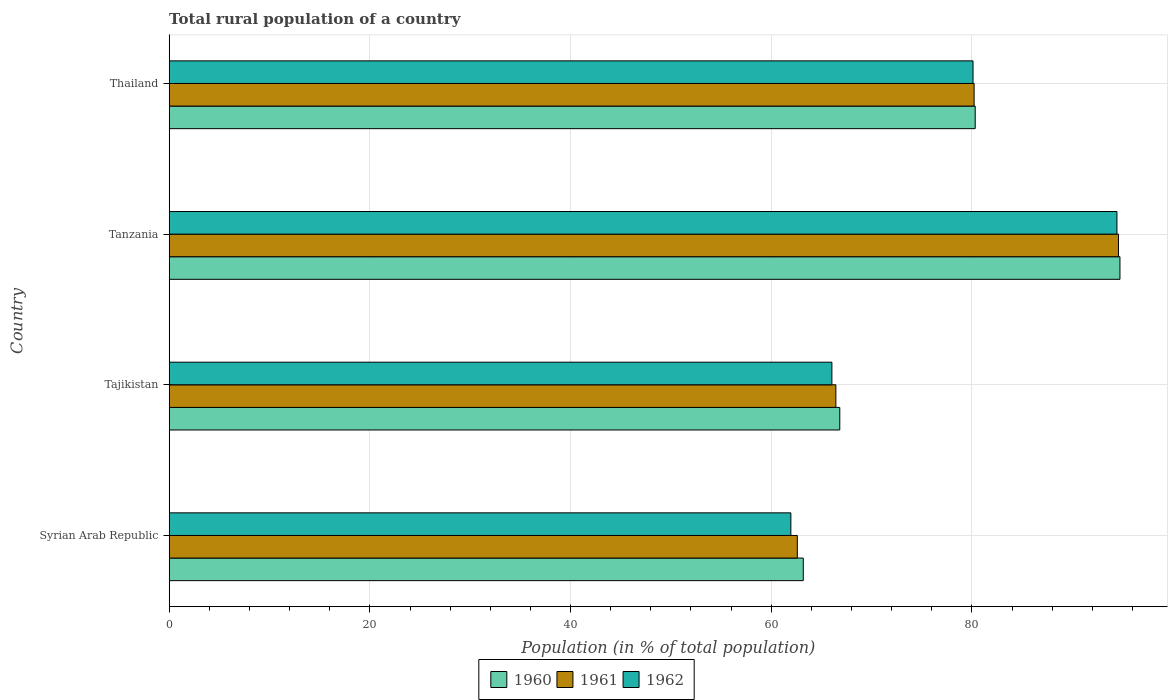How many different coloured bars are there?
Give a very brief answer. 3. How many groups of bars are there?
Keep it short and to the point. 4. Are the number of bars per tick equal to the number of legend labels?
Offer a very short reply. Yes. How many bars are there on the 3rd tick from the top?
Your answer should be compact. 3. What is the label of the 4th group of bars from the top?
Give a very brief answer. Syrian Arab Republic. What is the rural population in 1960 in Syrian Arab Republic?
Make the answer very short. 63.19. Across all countries, what is the maximum rural population in 1960?
Your answer should be very brief. 94.75. Across all countries, what is the minimum rural population in 1962?
Your response must be concise. 61.96. In which country was the rural population in 1962 maximum?
Ensure brevity in your answer.  Tanzania. In which country was the rural population in 1960 minimum?
Your response must be concise. Syrian Arab Republic. What is the total rural population in 1960 in the graph?
Offer a very short reply. 305.11. What is the difference between the rural population in 1961 in Syrian Arab Republic and that in Tanzania?
Your answer should be compact. -32. What is the difference between the rural population in 1960 in Syrian Arab Republic and the rural population in 1962 in Tanzania?
Make the answer very short. -31.26. What is the average rural population in 1961 per country?
Keep it short and to the point. 75.97. What is the difference between the rural population in 1960 and rural population in 1962 in Syrian Arab Republic?
Provide a short and direct response. 1.24. What is the ratio of the rural population in 1960 in Syrian Arab Republic to that in Thailand?
Your response must be concise. 0.79. What is the difference between the highest and the second highest rural population in 1961?
Ensure brevity in your answer.  14.39. What is the difference between the highest and the lowest rural population in 1961?
Provide a short and direct response. 32. What does the 3rd bar from the bottom in Tajikistan represents?
Offer a very short reply. 1962. Are the values on the major ticks of X-axis written in scientific E-notation?
Make the answer very short. No. Does the graph contain grids?
Your response must be concise. Yes. Where does the legend appear in the graph?
Offer a terse response. Bottom center. How many legend labels are there?
Make the answer very short. 3. How are the legend labels stacked?
Make the answer very short. Horizontal. What is the title of the graph?
Offer a very short reply. Total rural population of a country. What is the label or title of the X-axis?
Make the answer very short. Population (in % of total population). What is the label or title of the Y-axis?
Your response must be concise. Country. What is the Population (in % of total population) in 1960 in Syrian Arab Republic?
Your answer should be compact. 63.19. What is the Population (in % of total population) in 1961 in Syrian Arab Republic?
Make the answer very short. 62.6. What is the Population (in % of total population) of 1962 in Syrian Arab Republic?
Your response must be concise. 61.96. What is the Population (in % of total population) of 1960 in Tajikistan?
Keep it short and to the point. 66.83. What is the Population (in % of total population) of 1961 in Tajikistan?
Ensure brevity in your answer.  66.44. What is the Population (in % of total population) of 1962 in Tajikistan?
Your response must be concise. 66.05. What is the Population (in % of total population) of 1960 in Tanzania?
Keep it short and to the point. 94.75. What is the Population (in % of total population) of 1961 in Tanzania?
Offer a terse response. 94.61. What is the Population (in % of total population) in 1962 in Tanzania?
Keep it short and to the point. 94.45. What is the Population (in % of total population) in 1960 in Thailand?
Your answer should be very brief. 80.33. What is the Population (in % of total population) of 1961 in Thailand?
Offer a very short reply. 80.22. What is the Population (in % of total population) of 1962 in Thailand?
Ensure brevity in your answer.  80.11. Across all countries, what is the maximum Population (in % of total population) of 1960?
Your answer should be very brief. 94.75. Across all countries, what is the maximum Population (in % of total population) in 1961?
Provide a short and direct response. 94.61. Across all countries, what is the maximum Population (in % of total population) of 1962?
Your answer should be compact. 94.45. Across all countries, what is the minimum Population (in % of total population) in 1960?
Provide a short and direct response. 63.19. Across all countries, what is the minimum Population (in % of total population) in 1961?
Ensure brevity in your answer.  62.6. Across all countries, what is the minimum Population (in % of total population) of 1962?
Provide a short and direct response. 61.96. What is the total Population (in % of total population) of 1960 in the graph?
Make the answer very short. 305.11. What is the total Population (in % of total population) in 1961 in the graph?
Your answer should be compact. 303.87. What is the total Population (in % of total population) of 1962 in the graph?
Give a very brief answer. 302.56. What is the difference between the Population (in % of total population) of 1960 in Syrian Arab Republic and that in Tajikistan?
Offer a terse response. -3.64. What is the difference between the Population (in % of total population) of 1961 in Syrian Arab Republic and that in Tajikistan?
Make the answer very short. -3.84. What is the difference between the Population (in % of total population) of 1962 in Syrian Arab Republic and that in Tajikistan?
Ensure brevity in your answer.  -4.09. What is the difference between the Population (in % of total population) of 1960 in Syrian Arab Republic and that in Tanzania?
Keep it short and to the point. -31.56. What is the difference between the Population (in % of total population) of 1961 in Syrian Arab Republic and that in Tanzania?
Make the answer very short. -32.01. What is the difference between the Population (in % of total population) in 1962 in Syrian Arab Republic and that in Tanzania?
Keep it short and to the point. -32.5. What is the difference between the Population (in % of total population) in 1960 in Syrian Arab Republic and that in Thailand?
Offer a very short reply. -17.14. What is the difference between the Population (in % of total population) in 1961 in Syrian Arab Republic and that in Thailand?
Your answer should be very brief. -17.62. What is the difference between the Population (in % of total population) of 1962 in Syrian Arab Republic and that in Thailand?
Provide a succinct answer. -18.15. What is the difference between the Population (in % of total population) of 1960 in Tajikistan and that in Tanzania?
Keep it short and to the point. -27.92. What is the difference between the Population (in % of total population) of 1961 in Tajikistan and that in Tanzania?
Keep it short and to the point. -28.17. What is the difference between the Population (in % of total population) of 1962 in Tajikistan and that in Tanzania?
Ensure brevity in your answer.  -28.41. What is the difference between the Population (in % of total population) in 1960 in Tajikistan and that in Thailand?
Ensure brevity in your answer.  -13.5. What is the difference between the Population (in % of total population) of 1961 in Tajikistan and that in Thailand?
Your answer should be compact. -13.78. What is the difference between the Population (in % of total population) of 1962 in Tajikistan and that in Thailand?
Ensure brevity in your answer.  -14.06. What is the difference between the Population (in % of total population) in 1960 in Tanzania and that in Thailand?
Offer a very short reply. 14.43. What is the difference between the Population (in % of total population) of 1961 in Tanzania and that in Thailand?
Your answer should be very brief. 14.39. What is the difference between the Population (in % of total population) in 1962 in Tanzania and that in Thailand?
Your answer should be compact. 14.34. What is the difference between the Population (in % of total population) of 1960 in Syrian Arab Republic and the Population (in % of total population) of 1961 in Tajikistan?
Offer a very short reply. -3.25. What is the difference between the Population (in % of total population) in 1960 in Syrian Arab Republic and the Population (in % of total population) in 1962 in Tajikistan?
Offer a very short reply. -2.85. What is the difference between the Population (in % of total population) in 1961 in Syrian Arab Republic and the Population (in % of total population) in 1962 in Tajikistan?
Your response must be concise. -3.44. What is the difference between the Population (in % of total population) in 1960 in Syrian Arab Republic and the Population (in % of total population) in 1961 in Tanzania?
Make the answer very short. -31.41. What is the difference between the Population (in % of total population) of 1960 in Syrian Arab Republic and the Population (in % of total population) of 1962 in Tanzania?
Make the answer very short. -31.26. What is the difference between the Population (in % of total population) of 1961 in Syrian Arab Republic and the Population (in % of total population) of 1962 in Tanzania?
Your answer should be very brief. -31.85. What is the difference between the Population (in % of total population) in 1960 in Syrian Arab Republic and the Population (in % of total population) in 1961 in Thailand?
Your response must be concise. -17.03. What is the difference between the Population (in % of total population) in 1960 in Syrian Arab Republic and the Population (in % of total population) in 1962 in Thailand?
Provide a short and direct response. -16.92. What is the difference between the Population (in % of total population) in 1961 in Syrian Arab Republic and the Population (in % of total population) in 1962 in Thailand?
Your answer should be compact. -17.51. What is the difference between the Population (in % of total population) of 1960 in Tajikistan and the Population (in % of total population) of 1961 in Tanzania?
Provide a succinct answer. -27.77. What is the difference between the Population (in % of total population) in 1960 in Tajikistan and the Population (in % of total population) in 1962 in Tanzania?
Make the answer very short. -27.62. What is the difference between the Population (in % of total population) in 1961 in Tajikistan and the Population (in % of total population) in 1962 in Tanzania?
Make the answer very short. -28.01. What is the difference between the Population (in % of total population) in 1960 in Tajikistan and the Population (in % of total population) in 1961 in Thailand?
Your answer should be compact. -13.39. What is the difference between the Population (in % of total population) in 1960 in Tajikistan and the Population (in % of total population) in 1962 in Thailand?
Your answer should be compact. -13.28. What is the difference between the Population (in % of total population) of 1961 in Tajikistan and the Population (in % of total population) of 1962 in Thailand?
Provide a succinct answer. -13.67. What is the difference between the Population (in % of total population) in 1960 in Tanzania and the Population (in % of total population) in 1961 in Thailand?
Your answer should be compact. 14.54. What is the difference between the Population (in % of total population) in 1960 in Tanzania and the Population (in % of total population) in 1962 in Thailand?
Give a very brief answer. 14.64. What is the difference between the Population (in % of total population) in 1961 in Tanzania and the Population (in % of total population) in 1962 in Thailand?
Your answer should be compact. 14.5. What is the average Population (in % of total population) in 1960 per country?
Ensure brevity in your answer.  76.28. What is the average Population (in % of total population) of 1961 per country?
Provide a succinct answer. 75.97. What is the average Population (in % of total population) of 1962 per country?
Ensure brevity in your answer.  75.64. What is the difference between the Population (in % of total population) of 1960 and Population (in % of total population) of 1961 in Syrian Arab Republic?
Keep it short and to the point. 0.59. What is the difference between the Population (in % of total population) in 1960 and Population (in % of total population) in 1962 in Syrian Arab Republic?
Ensure brevity in your answer.  1.24. What is the difference between the Population (in % of total population) of 1961 and Population (in % of total population) of 1962 in Syrian Arab Republic?
Ensure brevity in your answer.  0.65. What is the difference between the Population (in % of total population) of 1960 and Population (in % of total population) of 1961 in Tajikistan?
Offer a very short reply. 0.39. What is the difference between the Population (in % of total population) in 1960 and Population (in % of total population) in 1962 in Tajikistan?
Provide a short and direct response. 0.79. What is the difference between the Population (in % of total population) of 1961 and Population (in % of total population) of 1962 in Tajikistan?
Offer a terse response. 0.4. What is the difference between the Population (in % of total population) in 1960 and Population (in % of total population) in 1961 in Tanzania?
Ensure brevity in your answer.  0.15. What is the difference between the Population (in % of total population) of 1960 and Population (in % of total population) of 1962 in Tanzania?
Keep it short and to the point. 0.3. What is the difference between the Population (in % of total population) in 1961 and Population (in % of total population) in 1962 in Tanzania?
Provide a short and direct response. 0.15. What is the difference between the Population (in % of total population) of 1960 and Population (in % of total population) of 1961 in Thailand?
Provide a short and direct response. 0.11. What is the difference between the Population (in % of total population) of 1960 and Population (in % of total population) of 1962 in Thailand?
Your answer should be very brief. 0.22. What is the difference between the Population (in % of total population) of 1961 and Population (in % of total population) of 1962 in Thailand?
Give a very brief answer. 0.11. What is the ratio of the Population (in % of total population) of 1960 in Syrian Arab Republic to that in Tajikistan?
Offer a very short reply. 0.95. What is the ratio of the Population (in % of total population) of 1961 in Syrian Arab Republic to that in Tajikistan?
Your response must be concise. 0.94. What is the ratio of the Population (in % of total population) of 1962 in Syrian Arab Republic to that in Tajikistan?
Your response must be concise. 0.94. What is the ratio of the Population (in % of total population) in 1960 in Syrian Arab Republic to that in Tanzania?
Your answer should be very brief. 0.67. What is the ratio of the Population (in % of total population) in 1961 in Syrian Arab Republic to that in Tanzania?
Offer a terse response. 0.66. What is the ratio of the Population (in % of total population) of 1962 in Syrian Arab Republic to that in Tanzania?
Your response must be concise. 0.66. What is the ratio of the Population (in % of total population) in 1960 in Syrian Arab Republic to that in Thailand?
Your response must be concise. 0.79. What is the ratio of the Population (in % of total population) in 1961 in Syrian Arab Republic to that in Thailand?
Ensure brevity in your answer.  0.78. What is the ratio of the Population (in % of total population) in 1962 in Syrian Arab Republic to that in Thailand?
Make the answer very short. 0.77. What is the ratio of the Population (in % of total population) of 1960 in Tajikistan to that in Tanzania?
Make the answer very short. 0.71. What is the ratio of the Population (in % of total population) in 1961 in Tajikistan to that in Tanzania?
Provide a short and direct response. 0.7. What is the ratio of the Population (in % of total population) of 1962 in Tajikistan to that in Tanzania?
Provide a succinct answer. 0.7. What is the ratio of the Population (in % of total population) of 1960 in Tajikistan to that in Thailand?
Offer a terse response. 0.83. What is the ratio of the Population (in % of total population) in 1961 in Tajikistan to that in Thailand?
Keep it short and to the point. 0.83. What is the ratio of the Population (in % of total population) in 1962 in Tajikistan to that in Thailand?
Your response must be concise. 0.82. What is the ratio of the Population (in % of total population) in 1960 in Tanzania to that in Thailand?
Provide a short and direct response. 1.18. What is the ratio of the Population (in % of total population) in 1961 in Tanzania to that in Thailand?
Make the answer very short. 1.18. What is the ratio of the Population (in % of total population) of 1962 in Tanzania to that in Thailand?
Provide a short and direct response. 1.18. What is the difference between the highest and the second highest Population (in % of total population) in 1960?
Give a very brief answer. 14.43. What is the difference between the highest and the second highest Population (in % of total population) of 1961?
Provide a succinct answer. 14.39. What is the difference between the highest and the second highest Population (in % of total population) of 1962?
Give a very brief answer. 14.34. What is the difference between the highest and the lowest Population (in % of total population) of 1960?
Provide a short and direct response. 31.56. What is the difference between the highest and the lowest Population (in % of total population) in 1961?
Provide a succinct answer. 32.01. What is the difference between the highest and the lowest Population (in % of total population) in 1962?
Provide a succinct answer. 32.5. 